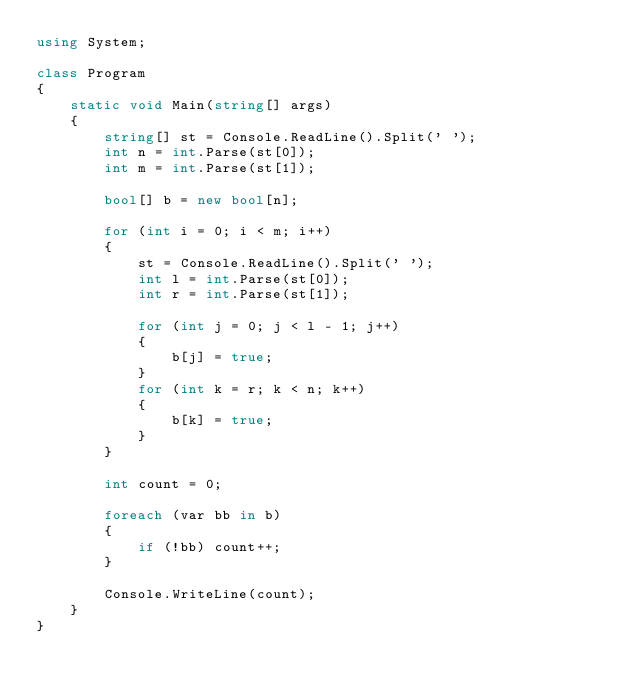Convert code to text. <code><loc_0><loc_0><loc_500><loc_500><_C#_>using System;

class Program
{
    static void Main(string[] args)
    {
        string[] st = Console.ReadLine().Split(' ');
        int n = int.Parse(st[0]);
        int m = int.Parse(st[1]);

        bool[] b = new bool[n];

        for (int i = 0; i < m; i++)
        {
            st = Console.ReadLine().Split(' ');
            int l = int.Parse(st[0]);
            int r = int.Parse(st[1]);
            
            for (int j = 0; j < l - 1; j++)
            {
                b[j] = true;
            }
            for (int k = r; k < n; k++)
            {
                b[k] = true;
            }
        }

        int count = 0;

        foreach (var bb in b)
        {
            if (!bb) count++;
        }

        Console.WriteLine(count);
    }
}</code> 